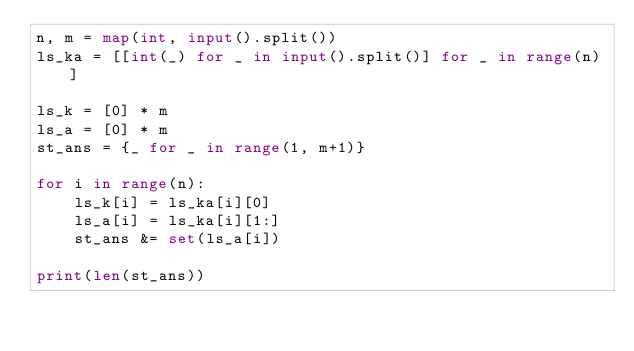Convert code to text. <code><loc_0><loc_0><loc_500><loc_500><_Python_>n, m = map(int, input().split())
ls_ka = [[int(_) for _ in input().split()] for _ in range(n)]

ls_k = [0] * m
ls_a = [0] * m
st_ans = {_ for _ in range(1, m+1)} 

for i in range(n):
    ls_k[i] = ls_ka[i][0]
    ls_a[i] = ls_ka[i][1:]
    st_ans &= set(ls_a[i])

print(len(st_ans))</code> 